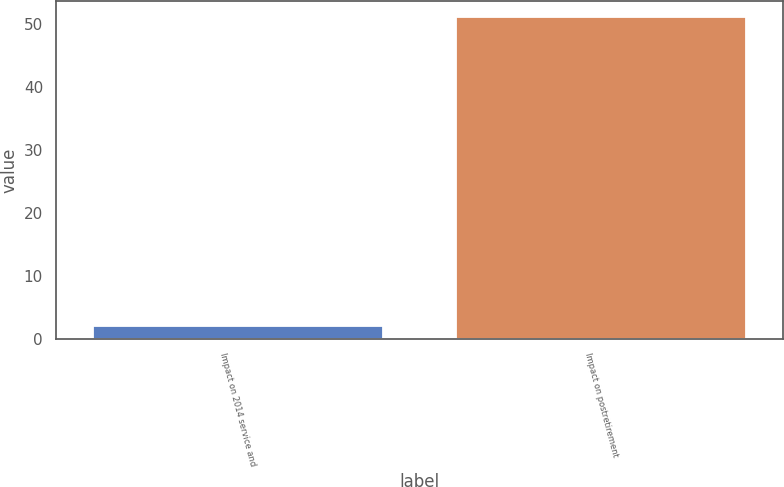Convert chart. <chart><loc_0><loc_0><loc_500><loc_500><bar_chart><fcel>Impact on 2014 service and<fcel>Impact on postretirement<nl><fcel>2<fcel>51<nl></chart> 